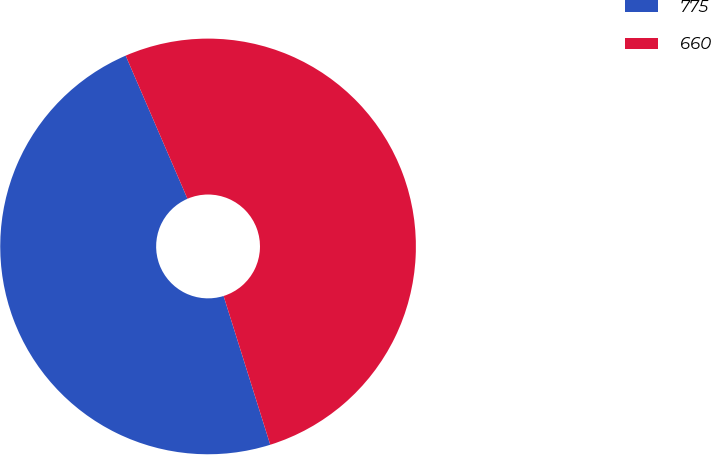Convert chart. <chart><loc_0><loc_0><loc_500><loc_500><pie_chart><fcel>775<fcel>660<nl><fcel>48.35%<fcel>51.65%<nl></chart> 